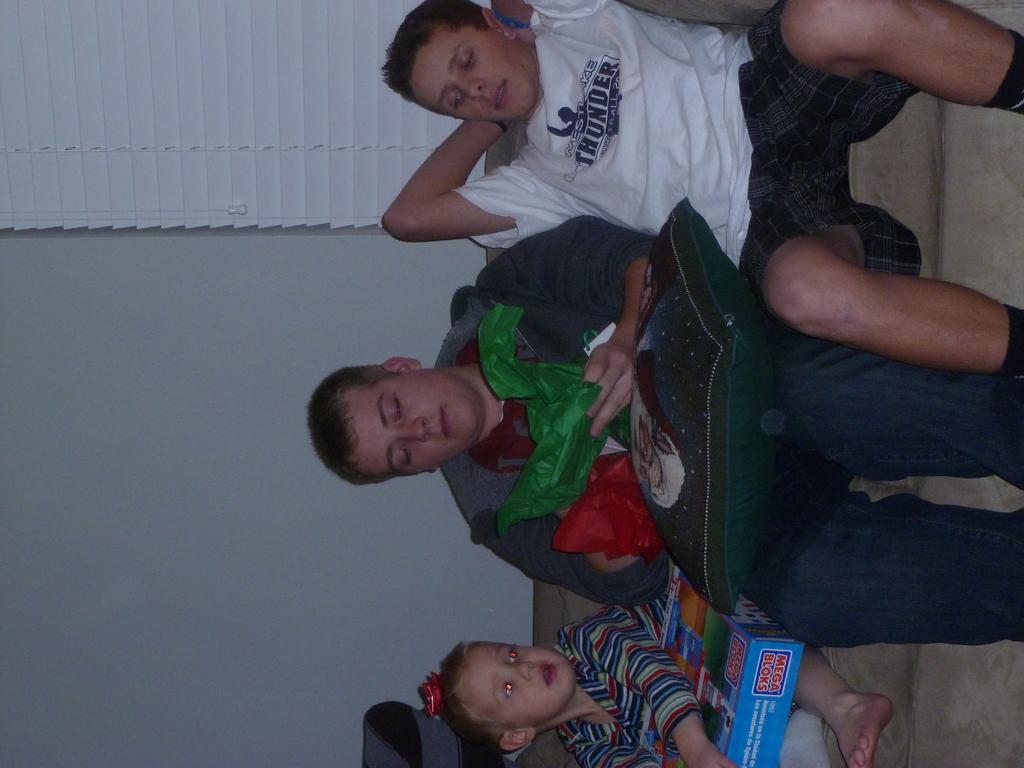Please provide a concise description of this image. In the foreground of this image, there are two men and a kid sitting on the couch. The man in the middle is holding a pillow and covers in his hand. In the background, we can see wall and the window blind. 